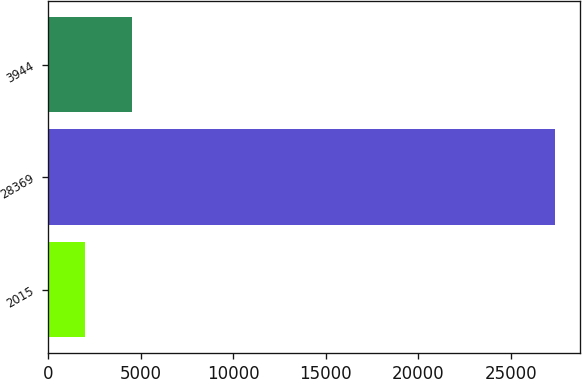Convert chart. <chart><loc_0><loc_0><loc_500><loc_500><bar_chart><fcel>2015<fcel>28369<fcel>3944<nl><fcel>2014<fcel>27380<fcel>4550.6<nl></chart> 